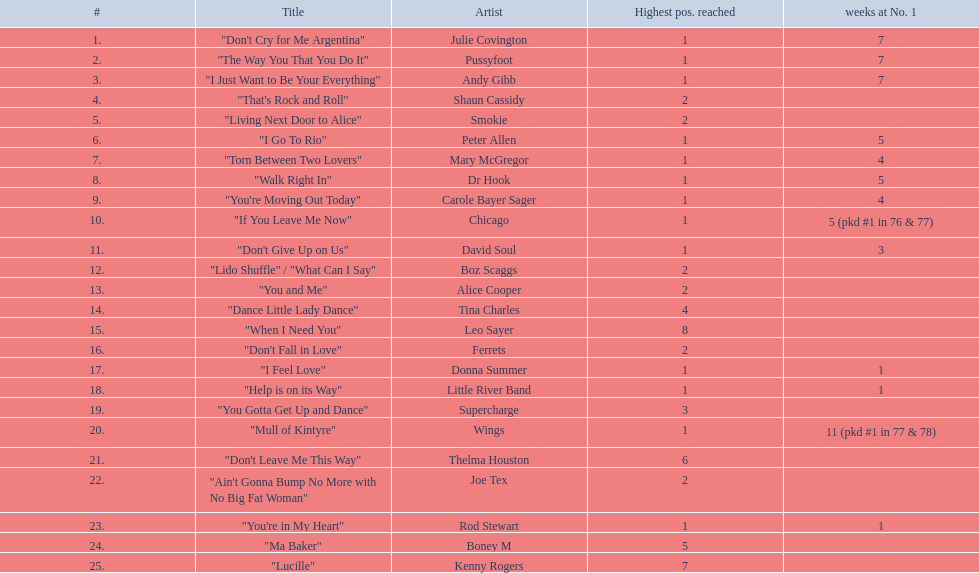Who experienced one of the shortest stints at the number one rank? Rod Stewart. Who didn't have any week at the top rank? Shaun Cassidy. Who held the record for the maximum weeks at the number one position? Wings. 